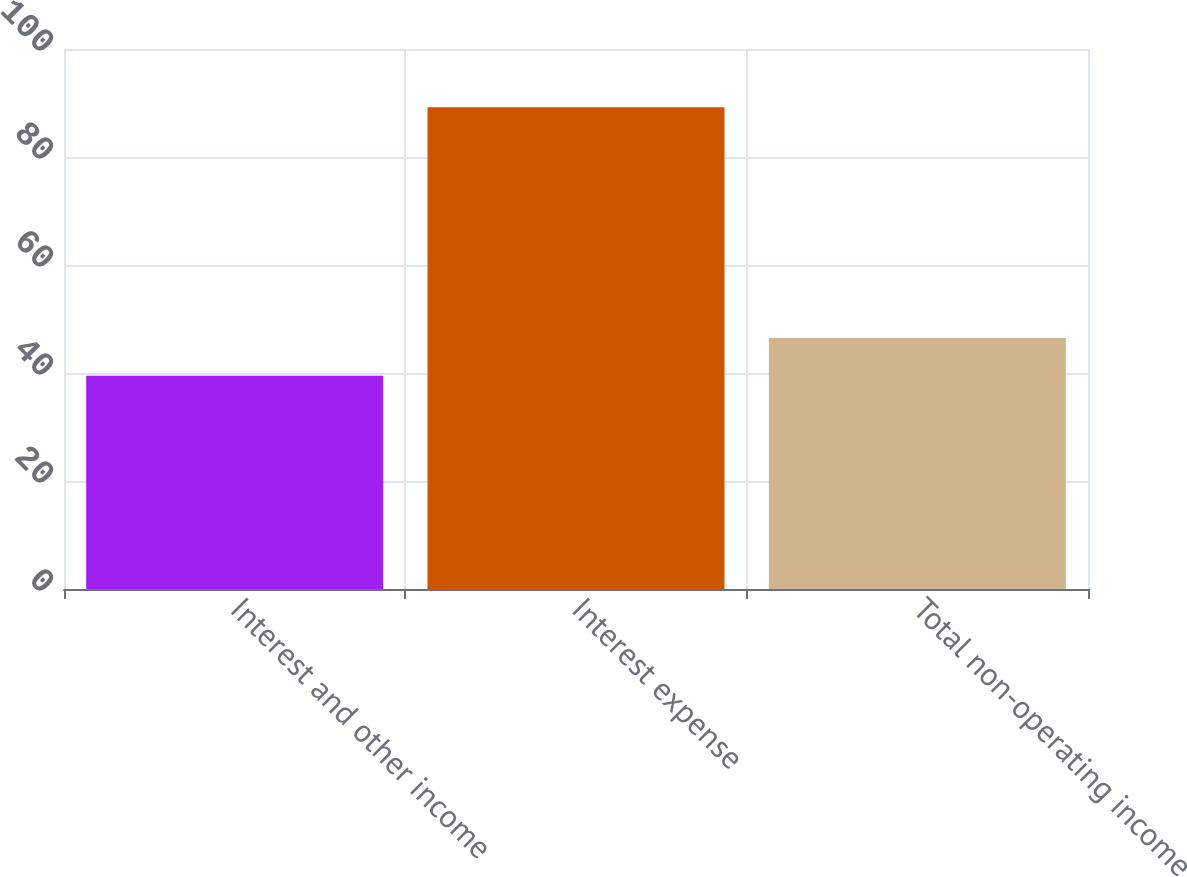<chart> <loc_0><loc_0><loc_500><loc_500><bar_chart><fcel>Interest and other income<fcel>Interest expense<fcel>Total non-operating income<nl><fcel>39.5<fcel>89.2<fcel>46.5<nl></chart> 